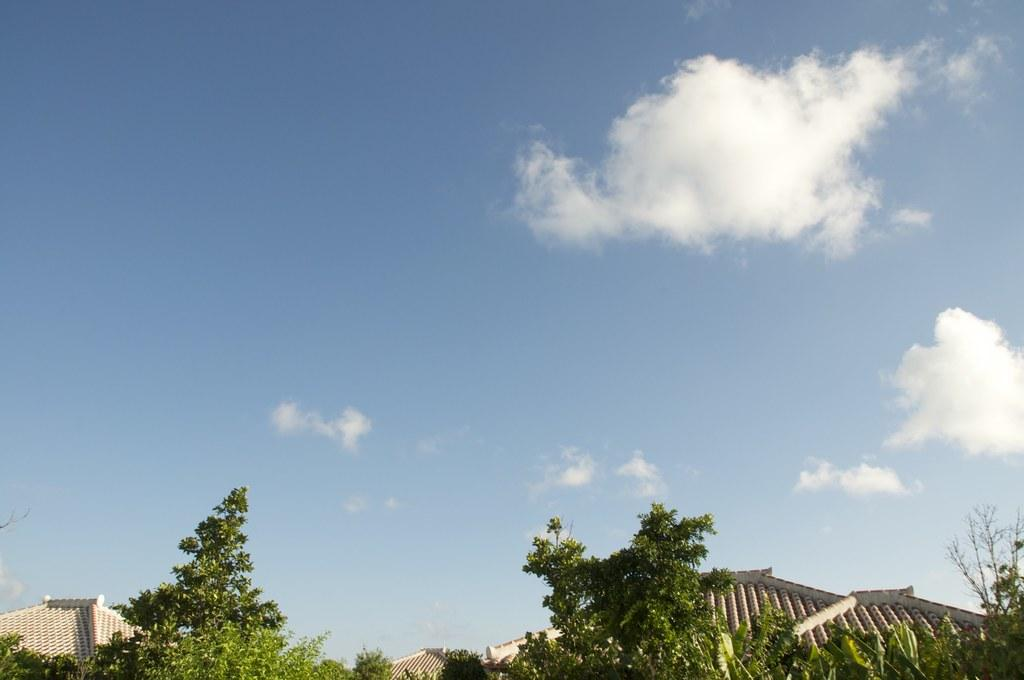What type of structures can be seen in the image? There are houses with roofs in the image. What other natural elements are present in the image? There are trees in the image. What part of the environment is visible in the image? The sky is visible in the image. How would you describe the sky in the image? The sky appears to be cloudy. Where is the hole that the hammer is trying to fix in the image? There is no hole or hammer present in the image. 